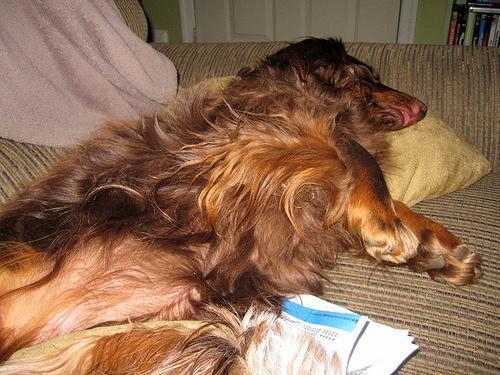How many dogs are pictured?
Give a very brief answer. 1. 